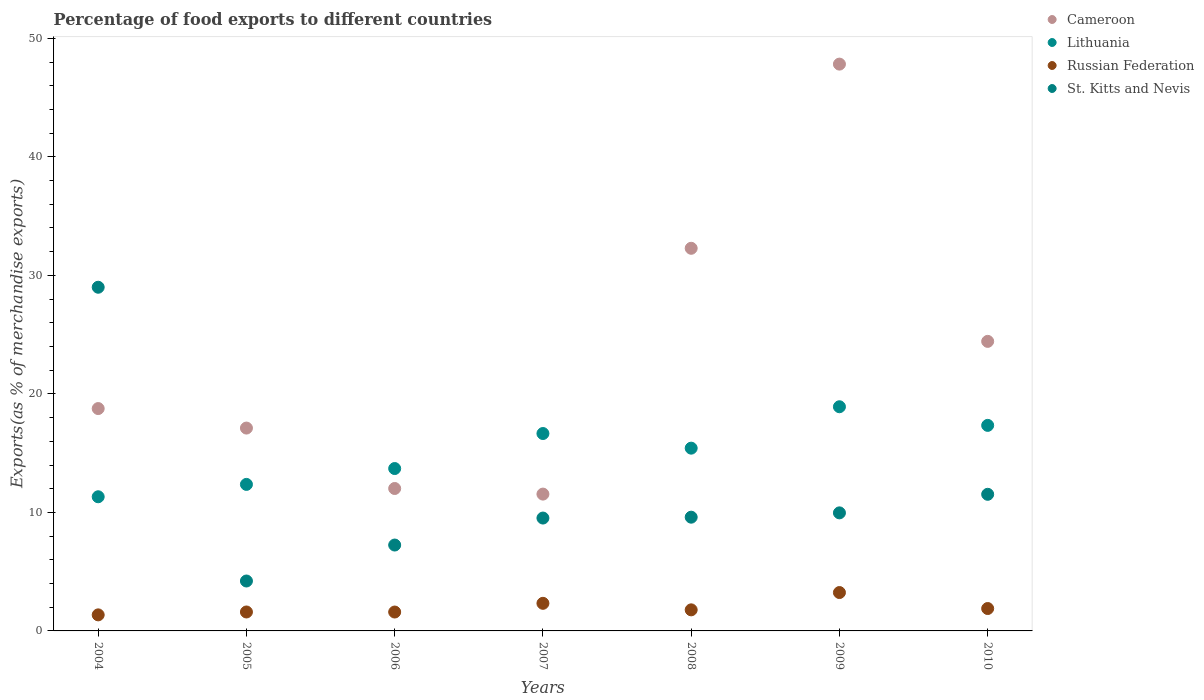Is the number of dotlines equal to the number of legend labels?
Provide a short and direct response. Yes. What is the percentage of exports to different countries in St. Kitts and Nevis in 2009?
Your answer should be compact. 9.96. Across all years, what is the maximum percentage of exports to different countries in Cameroon?
Make the answer very short. 47.83. Across all years, what is the minimum percentage of exports to different countries in St. Kitts and Nevis?
Your answer should be very brief. 4.21. In which year was the percentage of exports to different countries in St. Kitts and Nevis maximum?
Your answer should be very brief. 2004. What is the total percentage of exports to different countries in Lithuania in the graph?
Provide a succinct answer. 105.72. What is the difference between the percentage of exports to different countries in Russian Federation in 2007 and that in 2009?
Offer a terse response. -0.91. What is the difference between the percentage of exports to different countries in St. Kitts and Nevis in 2006 and the percentage of exports to different countries in Russian Federation in 2004?
Your answer should be compact. 5.89. What is the average percentage of exports to different countries in Lithuania per year?
Offer a very short reply. 15.1. In the year 2007, what is the difference between the percentage of exports to different countries in St. Kitts and Nevis and percentage of exports to different countries in Lithuania?
Your response must be concise. -7.13. In how many years, is the percentage of exports to different countries in St. Kitts and Nevis greater than 6 %?
Your response must be concise. 6. What is the ratio of the percentage of exports to different countries in St. Kitts and Nevis in 2005 to that in 2010?
Offer a very short reply. 0.37. Is the difference between the percentage of exports to different countries in St. Kitts and Nevis in 2004 and 2008 greater than the difference between the percentage of exports to different countries in Lithuania in 2004 and 2008?
Keep it short and to the point. Yes. What is the difference between the highest and the second highest percentage of exports to different countries in St. Kitts and Nevis?
Ensure brevity in your answer.  17.47. What is the difference between the highest and the lowest percentage of exports to different countries in St. Kitts and Nevis?
Your answer should be very brief. 24.79. In how many years, is the percentage of exports to different countries in Russian Federation greater than the average percentage of exports to different countries in Russian Federation taken over all years?
Offer a very short reply. 2. Is it the case that in every year, the sum of the percentage of exports to different countries in Russian Federation and percentage of exports to different countries in Cameroon  is greater than the sum of percentage of exports to different countries in St. Kitts and Nevis and percentage of exports to different countries in Lithuania?
Your answer should be compact. No. Is it the case that in every year, the sum of the percentage of exports to different countries in St. Kitts and Nevis and percentage of exports to different countries in Lithuania  is greater than the percentage of exports to different countries in Russian Federation?
Offer a very short reply. Yes. Is the percentage of exports to different countries in St. Kitts and Nevis strictly greater than the percentage of exports to different countries in Russian Federation over the years?
Keep it short and to the point. Yes. Is the percentage of exports to different countries in St. Kitts and Nevis strictly less than the percentage of exports to different countries in Cameroon over the years?
Your answer should be very brief. No. How many years are there in the graph?
Make the answer very short. 7. What is the difference between two consecutive major ticks on the Y-axis?
Provide a succinct answer. 10. What is the title of the graph?
Give a very brief answer. Percentage of food exports to different countries. What is the label or title of the X-axis?
Provide a succinct answer. Years. What is the label or title of the Y-axis?
Keep it short and to the point. Exports(as % of merchandise exports). What is the Exports(as % of merchandise exports) of Cameroon in 2004?
Offer a very short reply. 18.76. What is the Exports(as % of merchandise exports) of Lithuania in 2004?
Your answer should be compact. 11.32. What is the Exports(as % of merchandise exports) in Russian Federation in 2004?
Offer a very short reply. 1.35. What is the Exports(as % of merchandise exports) of St. Kitts and Nevis in 2004?
Keep it short and to the point. 29. What is the Exports(as % of merchandise exports) of Cameroon in 2005?
Ensure brevity in your answer.  17.12. What is the Exports(as % of merchandise exports) in Lithuania in 2005?
Your answer should be compact. 12.36. What is the Exports(as % of merchandise exports) in Russian Federation in 2005?
Your answer should be very brief. 1.6. What is the Exports(as % of merchandise exports) of St. Kitts and Nevis in 2005?
Ensure brevity in your answer.  4.21. What is the Exports(as % of merchandise exports) in Cameroon in 2006?
Offer a very short reply. 12.02. What is the Exports(as % of merchandise exports) in Lithuania in 2006?
Ensure brevity in your answer.  13.7. What is the Exports(as % of merchandise exports) in Russian Federation in 2006?
Make the answer very short. 1.59. What is the Exports(as % of merchandise exports) of St. Kitts and Nevis in 2006?
Your response must be concise. 7.25. What is the Exports(as % of merchandise exports) in Cameroon in 2007?
Offer a terse response. 11.54. What is the Exports(as % of merchandise exports) of Lithuania in 2007?
Your answer should be very brief. 16.66. What is the Exports(as % of merchandise exports) in Russian Federation in 2007?
Give a very brief answer. 2.33. What is the Exports(as % of merchandise exports) in St. Kitts and Nevis in 2007?
Make the answer very short. 9.52. What is the Exports(as % of merchandise exports) in Cameroon in 2008?
Provide a short and direct response. 32.29. What is the Exports(as % of merchandise exports) of Lithuania in 2008?
Provide a succinct answer. 15.42. What is the Exports(as % of merchandise exports) in Russian Federation in 2008?
Your answer should be compact. 1.78. What is the Exports(as % of merchandise exports) of St. Kitts and Nevis in 2008?
Keep it short and to the point. 9.6. What is the Exports(as % of merchandise exports) in Cameroon in 2009?
Offer a terse response. 47.83. What is the Exports(as % of merchandise exports) of Lithuania in 2009?
Make the answer very short. 18.92. What is the Exports(as % of merchandise exports) of Russian Federation in 2009?
Keep it short and to the point. 3.24. What is the Exports(as % of merchandise exports) in St. Kitts and Nevis in 2009?
Ensure brevity in your answer.  9.96. What is the Exports(as % of merchandise exports) of Cameroon in 2010?
Offer a very short reply. 24.43. What is the Exports(as % of merchandise exports) in Lithuania in 2010?
Ensure brevity in your answer.  17.34. What is the Exports(as % of merchandise exports) in Russian Federation in 2010?
Provide a succinct answer. 1.89. What is the Exports(as % of merchandise exports) in St. Kitts and Nevis in 2010?
Ensure brevity in your answer.  11.53. Across all years, what is the maximum Exports(as % of merchandise exports) of Cameroon?
Offer a very short reply. 47.83. Across all years, what is the maximum Exports(as % of merchandise exports) of Lithuania?
Your response must be concise. 18.92. Across all years, what is the maximum Exports(as % of merchandise exports) of Russian Federation?
Offer a very short reply. 3.24. Across all years, what is the maximum Exports(as % of merchandise exports) of St. Kitts and Nevis?
Provide a succinct answer. 29. Across all years, what is the minimum Exports(as % of merchandise exports) of Cameroon?
Keep it short and to the point. 11.54. Across all years, what is the minimum Exports(as % of merchandise exports) in Lithuania?
Keep it short and to the point. 11.32. Across all years, what is the minimum Exports(as % of merchandise exports) of Russian Federation?
Offer a very short reply. 1.35. Across all years, what is the minimum Exports(as % of merchandise exports) of St. Kitts and Nevis?
Keep it short and to the point. 4.21. What is the total Exports(as % of merchandise exports) in Cameroon in the graph?
Provide a succinct answer. 163.98. What is the total Exports(as % of merchandise exports) of Lithuania in the graph?
Your answer should be very brief. 105.72. What is the total Exports(as % of merchandise exports) in Russian Federation in the graph?
Ensure brevity in your answer.  13.78. What is the total Exports(as % of merchandise exports) in St. Kitts and Nevis in the graph?
Ensure brevity in your answer.  81.07. What is the difference between the Exports(as % of merchandise exports) in Cameroon in 2004 and that in 2005?
Your response must be concise. 1.65. What is the difference between the Exports(as % of merchandise exports) of Lithuania in 2004 and that in 2005?
Your response must be concise. -1.04. What is the difference between the Exports(as % of merchandise exports) in Russian Federation in 2004 and that in 2005?
Give a very brief answer. -0.24. What is the difference between the Exports(as % of merchandise exports) of St. Kitts and Nevis in 2004 and that in 2005?
Your answer should be compact. 24.79. What is the difference between the Exports(as % of merchandise exports) in Cameroon in 2004 and that in 2006?
Provide a short and direct response. 6.74. What is the difference between the Exports(as % of merchandise exports) of Lithuania in 2004 and that in 2006?
Provide a succinct answer. -2.38. What is the difference between the Exports(as % of merchandise exports) in Russian Federation in 2004 and that in 2006?
Offer a terse response. -0.24. What is the difference between the Exports(as % of merchandise exports) in St. Kitts and Nevis in 2004 and that in 2006?
Provide a short and direct response. 21.75. What is the difference between the Exports(as % of merchandise exports) in Cameroon in 2004 and that in 2007?
Offer a very short reply. 7.22. What is the difference between the Exports(as % of merchandise exports) in Lithuania in 2004 and that in 2007?
Your answer should be compact. -5.34. What is the difference between the Exports(as % of merchandise exports) of Russian Federation in 2004 and that in 2007?
Offer a terse response. -0.97. What is the difference between the Exports(as % of merchandise exports) in St. Kitts and Nevis in 2004 and that in 2007?
Keep it short and to the point. 19.48. What is the difference between the Exports(as % of merchandise exports) in Cameroon in 2004 and that in 2008?
Your response must be concise. -13.52. What is the difference between the Exports(as % of merchandise exports) of Lithuania in 2004 and that in 2008?
Keep it short and to the point. -4.1. What is the difference between the Exports(as % of merchandise exports) in Russian Federation in 2004 and that in 2008?
Provide a short and direct response. -0.42. What is the difference between the Exports(as % of merchandise exports) in St. Kitts and Nevis in 2004 and that in 2008?
Your answer should be compact. 19.4. What is the difference between the Exports(as % of merchandise exports) in Cameroon in 2004 and that in 2009?
Your answer should be compact. -29.06. What is the difference between the Exports(as % of merchandise exports) in Lithuania in 2004 and that in 2009?
Make the answer very short. -7.6. What is the difference between the Exports(as % of merchandise exports) in Russian Federation in 2004 and that in 2009?
Offer a terse response. -1.88. What is the difference between the Exports(as % of merchandise exports) in St. Kitts and Nevis in 2004 and that in 2009?
Provide a succinct answer. 19.04. What is the difference between the Exports(as % of merchandise exports) of Cameroon in 2004 and that in 2010?
Provide a succinct answer. -5.67. What is the difference between the Exports(as % of merchandise exports) in Lithuania in 2004 and that in 2010?
Ensure brevity in your answer.  -6.02. What is the difference between the Exports(as % of merchandise exports) of Russian Federation in 2004 and that in 2010?
Provide a short and direct response. -0.54. What is the difference between the Exports(as % of merchandise exports) in St. Kitts and Nevis in 2004 and that in 2010?
Keep it short and to the point. 17.47. What is the difference between the Exports(as % of merchandise exports) of Cameroon in 2005 and that in 2006?
Offer a terse response. 5.1. What is the difference between the Exports(as % of merchandise exports) of Lithuania in 2005 and that in 2006?
Make the answer very short. -1.34. What is the difference between the Exports(as % of merchandise exports) of Russian Federation in 2005 and that in 2006?
Keep it short and to the point. 0. What is the difference between the Exports(as % of merchandise exports) of St. Kitts and Nevis in 2005 and that in 2006?
Offer a terse response. -3.03. What is the difference between the Exports(as % of merchandise exports) in Cameroon in 2005 and that in 2007?
Make the answer very short. 5.57. What is the difference between the Exports(as % of merchandise exports) in Lithuania in 2005 and that in 2007?
Make the answer very short. -4.29. What is the difference between the Exports(as % of merchandise exports) in Russian Federation in 2005 and that in 2007?
Your answer should be very brief. -0.73. What is the difference between the Exports(as % of merchandise exports) in St. Kitts and Nevis in 2005 and that in 2007?
Keep it short and to the point. -5.31. What is the difference between the Exports(as % of merchandise exports) in Cameroon in 2005 and that in 2008?
Give a very brief answer. -15.17. What is the difference between the Exports(as % of merchandise exports) of Lithuania in 2005 and that in 2008?
Your response must be concise. -3.06. What is the difference between the Exports(as % of merchandise exports) of Russian Federation in 2005 and that in 2008?
Provide a succinct answer. -0.18. What is the difference between the Exports(as % of merchandise exports) in St. Kitts and Nevis in 2005 and that in 2008?
Your response must be concise. -5.38. What is the difference between the Exports(as % of merchandise exports) of Cameroon in 2005 and that in 2009?
Offer a terse response. -30.71. What is the difference between the Exports(as % of merchandise exports) in Lithuania in 2005 and that in 2009?
Provide a short and direct response. -6.55. What is the difference between the Exports(as % of merchandise exports) of Russian Federation in 2005 and that in 2009?
Keep it short and to the point. -1.64. What is the difference between the Exports(as % of merchandise exports) of St. Kitts and Nevis in 2005 and that in 2009?
Ensure brevity in your answer.  -5.75. What is the difference between the Exports(as % of merchandise exports) in Cameroon in 2005 and that in 2010?
Your answer should be very brief. -7.32. What is the difference between the Exports(as % of merchandise exports) of Lithuania in 2005 and that in 2010?
Offer a terse response. -4.98. What is the difference between the Exports(as % of merchandise exports) of Russian Federation in 2005 and that in 2010?
Offer a terse response. -0.29. What is the difference between the Exports(as % of merchandise exports) of St. Kitts and Nevis in 2005 and that in 2010?
Provide a short and direct response. -7.32. What is the difference between the Exports(as % of merchandise exports) of Cameroon in 2006 and that in 2007?
Offer a very short reply. 0.47. What is the difference between the Exports(as % of merchandise exports) of Lithuania in 2006 and that in 2007?
Keep it short and to the point. -2.96. What is the difference between the Exports(as % of merchandise exports) in Russian Federation in 2006 and that in 2007?
Make the answer very short. -0.73. What is the difference between the Exports(as % of merchandise exports) in St. Kitts and Nevis in 2006 and that in 2007?
Ensure brevity in your answer.  -2.28. What is the difference between the Exports(as % of merchandise exports) of Cameroon in 2006 and that in 2008?
Offer a very short reply. -20.27. What is the difference between the Exports(as % of merchandise exports) of Lithuania in 2006 and that in 2008?
Your answer should be very brief. -1.72. What is the difference between the Exports(as % of merchandise exports) of Russian Federation in 2006 and that in 2008?
Your answer should be very brief. -0.18. What is the difference between the Exports(as % of merchandise exports) of St. Kitts and Nevis in 2006 and that in 2008?
Provide a short and direct response. -2.35. What is the difference between the Exports(as % of merchandise exports) of Cameroon in 2006 and that in 2009?
Your response must be concise. -35.81. What is the difference between the Exports(as % of merchandise exports) in Lithuania in 2006 and that in 2009?
Keep it short and to the point. -5.21. What is the difference between the Exports(as % of merchandise exports) in Russian Federation in 2006 and that in 2009?
Give a very brief answer. -1.64. What is the difference between the Exports(as % of merchandise exports) in St. Kitts and Nevis in 2006 and that in 2009?
Give a very brief answer. -2.71. What is the difference between the Exports(as % of merchandise exports) in Cameroon in 2006 and that in 2010?
Offer a very short reply. -12.41. What is the difference between the Exports(as % of merchandise exports) of Lithuania in 2006 and that in 2010?
Your answer should be compact. -3.64. What is the difference between the Exports(as % of merchandise exports) in Russian Federation in 2006 and that in 2010?
Offer a very short reply. -0.3. What is the difference between the Exports(as % of merchandise exports) in St. Kitts and Nevis in 2006 and that in 2010?
Your response must be concise. -4.28. What is the difference between the Exports(as % of merchandise exports) in Cameroon in 2007 and that in 2008?
Provide a short and direct response. -20.74. What is the difference between the Exports(as % of merchandise exports) in Lithuania in 2007 and that in 2008?
Your response must be concise. 1.24. What is the difference between the Exports(as % of merchandise exports) of Russian Federation in 2007 and that in 2008?
Offer a very short reply. 0.55. What is the difference between the Exports(as % of merchandise exports) of St. Kitts and Nevis in 2007 and that in 2008?
Offer a terse response. -0.07. What is the difference between the Exports(as % of merchandise exports) of Cameroon in 2007 and that in 2009?
Your answer should be compact. -36.28. What is the difference between the Exports(as % of merchandise exports) of Lithuania in 2007 and that in 2009?
Keep it short and to the point. -2.26. What is the difference between the Exports(as % of merchandise exports) in Russian Federation in 2007 and that in 2009?
Your answer should be compact. -0.91. What is the difference between the Exports(as % of merchandise exports) of St. Kitts and Nevis in 2007 and that in 2009?
Give a very brief answer. -0.44. What is the difference between the Exports(as % of merchandise exports) of Cameroon in 2007 and that in 2010?
Make the answer very short. -12.89. What is the difference between the Exports(as % of merchandise exports) in Lithuania in 2007 and that in 2010?
Offer a terse response. -0.69. What is the difference between the Exports(as % of merchandise exports) of Russian Federation in 2007 and that in 2010?
Give a very brief answer. 0.44. What is the difference between the Exports(as % of merchandise exports) in St. Kitts and Nevis in 2007 and that in 2010?
Make the answer very short. -2. What is the difference between the Exports(as % of merchandise exports) of Cameroon in 2008 and that in 2009?
Your answer should be compact. -15.54. What is the difference between the Exports(as % of merchandise exports) in Lithuania in 2008 and that in 2009?
Provide a succinct answer. -3.49. What is the difference between the Exports(as % of merchandise exports) in Russian Federation in 2008 and that in 2009?
Ensure brevity in your answer.  -1.46. What is the difference between the Exports(as % of merchandise exports) in St. Kitts and Nevis in 2008 and that in 2009?
Make the answer very short. -0.36. What is the difference between the Exports(as % of merchandise exports) of Cameroon in 2008 and that in 2010?
Keep it short and to the point. 7.85. What is the difference between the Exports(as % of merchandise exports) of Lithuania in 2008 and that in 2010?
Provide a short and direct response. -1.92. What is the difference between the Exports(as % of merchandise exports) of Russian Federation in 2008 and that in 2010?
Make the answer very short. -0.11. What is the difference between the Exports(as % of merchandise exports) of St. Kitts and Nevis in 2008 and that in 2010?
Your answer should be very brief. -1.93. What is the difference between the Exports(as % of merchandise exports) of Cameroon in 2009 and that in 2010?
Make the answer very short. 23.39. What is the difference between the Exports(as % of merchandise exports) of Lithuania in 2009 and that in 2010?
Your answer should be very brief. 1.57. What is the difference between the Exports(as % of merchandise exports) in Russian Federation in 2009 and that in 2010?
Give a very brief answer. 1.35. What is the difference between the Exports(as % of merchandise exports) in St. Kitts and Nevis in 2009 and that in 2010?
Your answer should be very brief. -1.57. What is the difference between the Exports(as % of merchandise exports) in Cameroon in 2004 and the Exports(as % of merchandise exports) in Lithuania in 2005?
Provide a succinct answer. 6.4. What is the difference between the Exports(as % of merchandise exports) in Cameroon in 2004 and the Exports(as % of merchandise exports) in Russian Federation in 2005?
Keep it short and to the point. 17.16. What is the difference between the Exports(as % of merchandise exports) of Cameroon in 2004 and the Exports(as % of merchandise exports) of St. Kitts and Nevis in 2005?
Provide a short and direct response. 14.55. What is the difference between the Exports(as % of merchandise exports) of Lithuania in 2004 and the Exports(as % of merchandise exports) of Russian Federation in 2005?
Your answer should be compact. 9.72. What is the difference between the Exports(as % of merchandise exports) of Lithuania in 2004 and the Exports(as % of merchandise exports) of St. Kitts and Nevis in 2005?
Offer a terse response. 7.11. What is the difference between the Exports(as % of merchandise exports) of Russian Federation in 2004 and the Exports(as % of merchandise exports) of St. Kitts and Nevis in 2005?
Keep it short and to the point. -2.86. What is the difference between the Exports(as % of merchandise exports) of Cameroon in 2004 and the Exports(as % of merchandise exports) of Lithuania in 2006?
Provide a short and direct response. 5.06. What is the difference between the Exports(as % of merchandise exports) of Cameroon in 2004 and the Exports(as % of merchandise exports) of Russian Federation in 2006?
Ensure brevity in your answer.  17.17. What is the difference between the Exports(as % of merchandise exports) of Cameroon in 2004 and the Exports(as % of merchandise exports) of St. Kitts and Nevis in 2006?
Give a very brief answer. 11.52. What is the difference between the Exports(as % of merchandise exports) in Lithuania in 2004 and the Exports(as % of merchandise exports) in Russian Federation in 2006?
Give a very brief answer. 9.73. What is the difference between the Exports(as % of merchandise exports) in Lithuania in 2004 and the Exports(as % of merchandise exports) in St. Kitts and Nevis in 2006?
Make the answer very short. 4.07. What is the difference between the Exports(as % of merchandise exports) of Russian Federation in 2004 and the Exports(as % of merchandise exports) of St. Kitts and Nevis in 2006?
Offer a very short reply. -5.89. What is the difference between the Exports(as % of merchandise exports) in Cameroon in 2004 and the Exports(as % of merchandise exports) in Lithuania in 2007?
Your response must be concise. 2.11. What is the difference between the Exports(as % of merchandise exports) of Cameroon in 2004 and the Exports(as % of merchandise exports) of Russian Federation in 2007?
Offer a terse response. 16.43. What is the difference between the Exports(as % of merchandise exports) of Cameroon in 2004 and the Exports(as % of merchandise exports) of St. Kitts and Nevis in 2007?
Offer a very short reply. 9.24. What is the difference between the Exports(as % of merchandise exports) of Lithuania in 2004 and the Exports(as % of merchandise exports) of Russian Federation in 2007?
Offer a very short reply. 8.99. What is the difference between the Exports(as % of merchandise exports) of Lithuania in 2004 and the Exports(as % of merchandise exports) of St. Kitts and Nevis in 2007?
Give a very brief answer. 1.8. What is the difference between the Exports(as % of merchandise exports) of Russian Federation in 2004 and the Exports(as % of merchandise exports) of St. Kitts and Nevis in 2007?
Provide a succinct answer. -8.17. What is the difference between the Exports(as % of merchandise exports) in Cameroon in 2004 and the Exports(as % of merchandise exports) in Lithuania in 2008?
Offer a terse response. 3.34. What is the difference between the Exports(as % of merchandise exports) in Cameroon in 2004 and the Exports(as % of merchandise exports) in Russian Federation in 2008?
Provide a succinct answer. 16.98. What is the difference between the Exports(as % of merchandise exports) in Cameroon in 2004 and the Exports(as % of merchandise exports) in St. Kitts and Nevis in 2008?
Your answer should be very brief. 9.17. What is the difference between the Exports(as % of merchandise exports) in Lithuania in 2004 and the Exports(as % of merchandise exports) in Russian Federation in 2008?
Your answer should be compact. 9.54. What is the difference between the Exports(as % of merchandise exports) in Lithuania in 2004 and the Exports(as % of merchandise exports) in St. Kitts and Nevis in 2008?
Provide a short and direct response. 1.72. What is the difference between the Exports(as % of merchandise exports) in Russian Federation in 2004 and the Exports(as % of merchandise exports) in St. Kitts and Nevis in 2008?
Keep it short and to the point. -8.24. What is the difference between the Exports(as % of merchandise exports) of Cameroon in 2004 and the Exports(as % of merchandise exports) of Lithuania in 2009?
Keep it short and to the point. -0.15. What is the difference between the Exports(as % of merchandise exports) of Cameroon in 2004 and the Exports(as % of merchandise exports) of Russian Federation in 2009?
Your answer should be very brief. 15.52. What is the difference between the Exports(as % of merchandise exports) in Cameroon in 2004 and the Exports(as % of merchandise exports) in St. Kitts and Nevis in 2009?
Your response must be concise. 8.8. What is the difference between the Exports(as % of merchandise exports) of Lithuania in 2004 and the Exports(as % of merchandise exports) of Russian Federation in 2009?
Your answer should be very brief. 8.08. What is the difference between the Exports(as % of merchandise exports) of Lithuania in 2004 and the Exports(as % of merchandise exports) of St. Kitts and Nevis in 2009?
Your response must be concise. 1.36. What is the difference between the Exports(as % of merchandise exports) of Russian Federation in 2004 and the Exports(as % of merchandise exports) of St. Kitts and Nevis in 2009?
Your answer should be very brief. -8.61. What is the difference between the Exports(as % of merchandise exports) of Cameroon in 2004 and the Exports(as % of merchandise exports) of Lithuania in 2010?
Keep it short and to the point. 1.42. What is the difference between the Exports(as % of merchandise exports) in Cameroon in 2004 and the Exports(as % of merchandise exports) in Russian Federation in 2010?
Keep it short and to the point. 16.87. What is the difference between the Exports(as % of merchandise exports) of Cameroon in 2004 and the Exports(as % of merchandise exports) of St. Kitts and Nevis in 2010?
Give a very brief answer. 7.23. What is the difference between the Exports(as % of merchandise exports) of Lithuania in 2004 and the Exports(as % of merchandise exports) of Russian Federation in 2010?
Provide a short and direct response. 9.43. What is the difference between the Exports(as % of merchandise exports) of Lithuania in 2004 and the Exports(as % of merchandise exports) of St. Kitts and Nevis in 2010?
Provide a succinct answer. -0.21. What is the difference between the Exports(as % of merchandise exports) of Russian Federation in 2004 and the Exports(as % of merchandise exports) of St. Kitts and Nevis in 2010?
Your answer should be very brief. -10.17. What is the difference between the Exports(as % of merchandise exports) in Cameroon in 2005 and the Exports(as % of merchandise exports) in Lithuania in 2006?
Your answer should be very brief. 3.41. What is the difference between the Exports(as % of merchandise exports) of Cameroon in 2005 and the Exports(as % of merchandise exports) of Russian Federation in 2006?
Keep it short and to the point. 15.52. What is the difference between the Exports(as % of merchandise exports) of Cameroon in 2005 and the Exports(as % of merchandise exports) of St. Kitts and Nevis in 2006?
Keep it short and to the point. 9.87. What is the difference between the Exports(as % of merchandise exports) in Lithuania in 2005 and the Exports(as % of merchandise exports) in Russian Federation in 2006?
Give a very brief answer. 10.77. What is the difference between the Exports(as % of merchandise exports) in Lithuania in 2005 and the Exports(as % of merchandise exports) in St. Kitts and Nevis in 2006?
Give a very brief answer. 5.12. What is the difference between the Exports(as % of merchandise exports) in Russian Federation in 2005 and the Exports(as % of merchandise exports) in St. Kitts and Nevis in 2006?
Your response must be concise. -5.65. What is the difference between the Exports(as % of merchandise exports) of Cameroon in 2005 and the Exports(as % of merchandise exports) of Lithuania in 2007?
Give a very brief answer. 0.46. What is the difference between the Exports(as % of merchandise exports) in Cameroon in 2005 and the Exports(as % of merchandise exports) in Russian Federation in 2007?
Offer a very short reply. 14.79. What is the difference between the Exports(as % of merchandise exports) in Cameroon in 2005 and the Exports(as % of merchandise exports) in St. Kitts and Nevis in 2007?
Your response must be concise. 7.59. What is the difference between the Exports(as % of merchandise exports) of Lithuania in 2005 and the Exports(as % of merchandise exports) of Russian Federation in 2007?
Ensure brevity in your answer.  10.03. What is the difference between the Exports(as % of merchandise exports) in Lithuania in 2005 and the Exports(as % of merchandise exports) in St. Kitts and Nevis in 2007?
Your answer should be compact. 2.84. What is the difference between the Exports(as % of merchandise exports) in Russian Federation in 2005 and the Exports(as % of merchandise exports) in St. Kitts and Nevis in 2007?
Ensure brevity in your answer.  -7.93. What is the difference between the Exports(as % of merchandise exports) in Cameroon in 2005 and the Exports(as % of merchandise exports) in Lithuania in 2008?
Ensure brevity in your answer.  1.69. What is the difference between the Exports(as % of merchandise exports) of Cameroon in 2005 and the Exports(as % of merchandise exports) of Russian Federation in 2008?
Offer a terse response. 15.34. What is the difference between the Exports(as % of merchandise exports) of Cameroon in 2005 and the Exports(as % of merchandise exports) of St. Kitts and Nevis in 2008?
Offer a very short reply. 7.52. What is the difference between the Exports(as % of merchandise exports) of Lithuania in 2005 and the Exports(as % of merchandise exports) of Russian Federation in 2008?
Ensure brevity in your answer.  10.59. What is the difference between the Exports(as % of merchandise exports) in Lithuania in 2005 and the Exports(as % of merchandise exports) in St. Kitts and Nevis in 2008?
Give a very brief answer. 2.77. What is the difference between the Exports(as % of merchandise exports) in Russian Federation in 2005 and the Exports(as % of merchandise exports) in St. Kitts and Nevis in 2008?
Your answer should be very brief. -8. What is the difference between the Exports(as % of merchandise exports) in Cameroon in 2005 and the Exports(as % of merchandise exports) in Lithuania in 2009?
Keep it short and to the point. -1.8. What is the difference between the Exports(as % of merchandise exports) in Cameroon in 2005 and the Exports(as % of merchandise exports) in Russian Federation in 2009?
Keep it short and to the point. 13.88. What is the difference between the Exports(as % of merchandise exports) in Cameroon in 2005 and the Exports(as % of merchandise exports) in St. Kitts and Nevis in 2009?
Your answer should be compact. 7.15. What is the difference between the Exports(as % of merchandise exports) in Lithuania in 2005 and the Exports(as % of merchandise exports) in Russian Federation in 2009?
Your answer should be very brief. 9.12. What is the difference between the Exports(as % of merchandise exports) in Lithuania in 2005 and the Exports(as % of merchandise exports) in St. Kitts and Nevis in 2009?
Offer a very short reply. 2.4. What is the difference between the Exports(as % of merchandise exports) in Russian Federation in 2005 and the Exports(as % of merchandise exports) in St. Kitts and Nevis in 2009?
Provide a succinct answer. -8.36. What is the difference between the Exports(as % of merchandise exports) in Cameroon in 2005 and the Exports(as % of merchandise exports) in Lithuania in 2010?
Provide a short and direct response. -0.23. What is the difference between the Exports(as % of merchandise exports) in Cameroon in 2005 and the Exports(as % of merchandise exports) in Russian Federation in 2010?
Your answer should be compact. 15.23. What is the difference between the Exports(as % of merchandise exports) in Cameroon in 2005 and the Exports(as % of merchandise exports) in St. Kitts and Nevis in 2010?
Ensure brevity in your answer.  5.59. What is the difference between the Exports(as % of merchandise exports) of Lithuania in 2005 and the Exports(as % of merchandise exports) of Russian Federation in 2010?
Make the answer very short. 10.47. What is the difference between the Exports(as % of merchandise exports) in Lithuania in 2005 and the Exports(as % of merchandise exports) in St. Kitts and Nevis in 2010?
Your answer should be very brief. 0.84. What is the difference between the Exports(as % of merchandise exports) of Russian Federation in 2005 and the Exports(as % of merchandise exports) of St. Kitts and Nevis in 2010?
Provide a succinct answer. -9.93. What is the difference between the Exports(as % of merchandise exports) of Cameroon in 2006 and the Exports(as % of merchandise exports) of Lithuania in 2007?
Your answer should be compact. -4.64. What is the difference between the Exports(as % of merchandise exports) of Cameroon in 2006 and the Exports(as % of merchandise exports) of Russian Federation in 2007?
Your answer should be very brief. 9.69. What is the difference between the Exports(as % of merchandise exports) in Cameroon in 2006 and the Exports(as % of merchandise exports) in St. Kitts and Nevis in 2007?
Ensure brevity in your answer.  2.49. What is the difference between the Exports(as % of merchandise exports) in Lithuania in 2006 and the Exports(as % of merchandise exports) in Russian Federation in 2007?
Provide a succinct answer. 11.37. What is the difference between the Exports(as % of merchandise exports) of Lithuania in 2006 and the Exports(as % of merchandise exports) of St. Kitts and Nevis in 2007?
Your response must be concise. 4.18. What is the difference between the Exports(as % of merchandise exports) in Russian Federation in 2006 and the Exports(as % of merchandise exports) in St. Kitts and Nevis in 2007?
Keep it short and to the point. -7.93. What is the difference between the Exports(as % of merchandise exports) in Cameroon in 2006 and the Exports(as % of merchandise exports) in Lithuania in 2008?
Keep it short and to the point. -3.4. What is the difference between the Exports(as % of merchandise exports) of Cameroon in 2006 and the Exports(as % of merchandise exports) of Russian Federation in 2008?
Make the answer very short. 10.24. What is the difference between the Exports(as % of merchandise exports) of Cameroon in 2006 and the Exports(as % of merchandise exports) of St. Kitts and Nevis in 2008?
Provide a short and direct response. 2.42. What is the difference between the Exports(as % of merchandise exports) in Lithuania in 2006 and the Exports(as % of merchandise exports) in Russian Federation in 2008?
Offer a terse response. 11.92. What is the difference between the Exports(as % of merchandise exports) in Lithuania in 2006 and the Exports(as % of merchandise exports) in St. Kitts and Nevis in 2008?
Give a very brief answer. 4.1. What is the difference between the Exports(as % of merchandise exports) of Russian Federation in 2006 and the Exports(as % of merchandise exports) of St. Kitts and Nevis in 2008?
Your answer should be very brief. -8. What is the difference between the Exports(as % of merchandise exports) in Cameroon in 2006 and the Exports(as % of merchandise exports) in Lithuania in 2009?
Provide a short and direct response. -6.9. What is the difference between the Exports(as % of merchandise exports) of Cameroon in 2006 and the Exports(as % of merchandise exports) of Russian Federation in 2009?
Your answer should be very brief. 8.78. What is the difference between the Exports(as % of merchandise exports) in Cameroon in 2006 and the Exports(as % of merchandise exports) in St. Kitts and Nevis in 2009?
Offer a terse response. 2.06. What is the difference between the Exports(as % of merchandise exports) of Lithuania in 2006 and the Exports(as % of merchandise exports) of Russian Federation in 2009?
Offer a terse response. 10.46. What is the difference between the Exports(as % of merchandise exports) in Lithuania in 2006 and the Exports(as % of merchandise exports) in St. Kitts and Nevis in 2009?
Ensure brevity in your answer.  3.74. What is the difference between the Exports(as % of merchandise exports) of Russian Federation in 2006 and the Exports(as % of merchandise exports) of St. Kitts and Nevis in 2009?
Make the answer very short. -8.37. What is the difference between the Exports(as % of merchandise exports) of Cameroon in 2006 and the Exports(as % of merchandise exports) of Lithuania in 2010?
Offer a terse response. -5.33. What is the difference between the Exports(as % of merchandise exports) of Cameroon in 2006 and the Exports(as % of merchandise exports) of Russian Federation in 2010?
Your answer should be very brief. 10.13. What is the difference between the Exports(as % of merchandise exports) in Cameroon in 2006 and the Exports(as % of merchandise exports) in St. Kitts and Nevis in 2010?
Ensure brevity in your answer.  0.49. What is the difference between the Exports(as % of merchandise exports) in Lithuania in 2006 and the Exports(as % of merchandise exports) in Russian Federation in 2010?
Make the answer very short. 11.81. What is the difference between the Exports(as % of merchandise exports) in Lithuania in 2006 and the Exports(as % of merchandise exports) in St. Kitts and Nevis in 2010?
Your response must be concise. 2.17. What is the difference between the Exports(as % of merchandise exports) in Russian Federation in 2006 and the Exports(as % of merchandise exports) in St. Kitts and Nevis in 2010?
Keep it short and to the point. -9.93. What is the difference between the Exports(as % of merchandise exports) in Cameroon in 2007 and the Exports(as % of merchandise exports) in Lithuania in 2008?
Make the answer very short. -3.88. What is the difference between the Exports(as % of merchandise exports) of Cameroon in 2007 and the Exports(as % of merchandise exports) of Russian Federation in 2008?
Provide a short and direct response. 9.77. What is the difference between the Exports(as % of merchandise exports) of Cameroon in 2007 and the Exports(as % of merchandise exports) of St. Kitts and Nevis in 2008?
Offer a very short reply. 1.95. What is the difference between the Exports(as % of merchandise exports) of Lithuania in 2007 and the Exports(as % of merchandise exports) of Russian Federation in 2008?
Make the answer very short. 14.88. What is the difference between the Exports(as % of merchandise exports) in Lithuania in 2007 and the Exports(as % of merchandise exports) in St. Kitts and Nevis in 2008?
Provide a succinct answer. 7.06. What is the difference between the Exports(as % of merchandise exports) in Russian Federation in 2007 and the Exports(as % of merchandise exports) in St. Kitts and Nevis in 2008?
Ensure brevity in your answer.  -7.27. What is the difference between the Exports(as % of merchandise exports) in Cameroon in 2007 and the Exports(as % of merchandise exports) in Lithuania in 2009?
Ensure brevity in your answer.  -7.37. What is the difference between the Exports(as % of merchandise exports) of Cameroon in 2007 and the Exports(as % of merchandise exports) of Russian Federation in 2009?
Make the answer very short. 8.31. What is the difference between the Exports(as % of merchandise exports) in Cameroon in 2007 and the Exports(as % of merchandise exports) in St. Kitts and Nevis in 2009?
Offer a terse response. 1.58. What is the difference between the Exports(as % of merchandise exports) in Lithuania in 2007 and the Exports(as % of merchandise exports) in Russian Federation in 2009?
Make the answer very short. 13.42. What is the difference between the Exports(as % of merchandise exports) of Lithuania in 2007 and the Exports(as % of merchandise exports) of St. Kitts and Nevis in 2009?
Your answer should be compact. 6.69. What is the difference between the Exports(as % of merchandise exports) of Russian Federation in 2007 and the Exports(as % of merchandise exports) of St. Kitts and Nevis in 2009?
Provide a succinct answer. -7.63. What is the difference between the Exports(as % of merchandise exports) in Cameroon in 2007 and the Exports(as % of merchandise exports) in Lithuania in 2010?
Offer a terse response. -5.8. What is the difference between the Exports(as % of merchandise exports) in Cameroon in 2007 and the Exports(as % of merchandise exports) in Russian Federation in 2010?
Offer a terse response. 9.65. What is the difference between the Exports(as % of merchandise exports) of Cameroon in 2007 and the Exports(as % of merchandise exports) of St. Kitts and Nevis in 2010?
Offer a terse response. 0.02. What is the difference between the Exports(as % of merchandise exports) of Lithuania in 2007 and the Exports(as % of merchandise exports) of Russian Federation in 2010?
Your answer should be very brief. 14.77. What is the difference between the Exports(as % of merchandise exports) in Lithuania in 2007 and the Exports(as % of merchandise exports) in St. Kitts and Nevis in 2010?
Keep it short and to the point. 5.13. What is the difference between the Exports(as % of merchandise exports) of Russian Federation in 2007 and the Exports(as % of merchandise exports) of St. Kitts and Nevis in 2010?
Your response must be concise. -9.2. What is the difference between the Exports(as % of merchandise exports) of Cameroon in 2008 and the Exports(as % of merchandise exports) of Lithuania in 2009?
Make the answer very short. 13.37. What is the difference between the Exports(as % of merchandise exports) of Cameroon in 2008 and the Exports(as % of merchandise exports) of Russian Federation in 2009?
Your response must be concise. 29.05. What is the difference between the Exports(as % of merchandise exports) in Cameroon in 2008 and the Exports(as % of merchandise exports) in St. Kitts and Nevis in 2009?
Offer a very short reply. 22.32. What is the difference between the Exports(as % of merchandise exports) of Lithuania in 2008 and the Exports(as % of merchandise exports) of Russian Federation in 2009?
Provide a succinct answer. 12.18. What is the difference between the Exports(as % of merchandise exports) in Lithuania in 2008 and the Exports(as % of merchandise exports) in St. Kitts and Nevis in 2009?
Your response must be concise. 5.46. What is the difference between the Exports(as % of merchandise exports) in Russian Federation in 2008 and the Exports(as % of merchandise exports) in St. Kitts and Nevis in 2009?
Your answer should be very brief. -8.18. What is the difference between the Exports(as % of merchandise exports) of Cameroon in 2008 and the Exports(as % of merchandise exports) of Lithuania in 2010?
Your answer should be very brief. 14.94. What is the difference between the Exports(as % of merchandise exports) in Cameroon in 2008 and the Exports(as % of merchandise exports) in Russian Federation in 2010?
Your answer should be compact. 30.4. What is the difference between the Exports(as % of merchandise exports) in Cameroon in 2008 and the Exports(as % of merchandise exports) in St. Kitts and Nevis in 2010?
Your response must be concise. 20.76. What is the difference between the Exports(as % of merchandise exports) in Lithuania in 2008 and the Exports(as % of merchandise exports) in Russian Federation in 2010?
Ensure brevity in your answer.  13.53. What is the difference between the Exports(as % of merchandise exports) in Lithuania in 2008 and the Exports(as % of merchandise exports) in St. Kitts and Nevis in 2010?
Your answer should be very brief. 3.89. What is the difference between the Exports(as % of merchandise exports) in Russian Federation in 2008 and the Exports(as % of merchandise exports) in St. Kitts and Nevis in 2010?
Make the answer very short. -9.75. What is the difference between the Exports(as % of merchandise exports) of Cameroon in 2009 and the Exports(as % of merchandise exports) of Lithuania in 2010?
Offer a terse response. 30.48. What is the difference between the Exports(as % of merchandise exports) of Cameroon in 2009 and the Exports(as % of merchandise exports) of Russian Federation in 2010?
Give a very brief answer. 45.94. What is the difference between the Exports(as % of merchandise exports) in Cameroon in 2009 and the Exports(as % of merchandise exports) in St. Kitts and Nevis in 2010?
Ensure brevity in your answer.  36.3. What is the difference between the Exports(as % of merchandise exports) of Lithuania in 2009 and the Exports(as % of merchandise exports) of Russian Federation in 2010?
Your answer should be compact. 17.03. What is the difference between the Exports(as % of merchandise exports) of Lithuania in 2009 and the Exports(as % of merchandise exports) of St. Kitts and Nevis in 2010?
Your answer should be very brief. 7.39. What is the difference between the Exports(as % of merchandise exports) of Russian Federation in 2009 and the Exports(as % of merchandise exports) of St. Kitts and Nevis in 2010?
Make the answer very short. -8.29. What is the average Exports(as % of merchandise exports) of Cameroon per year?
Your response must be concise. 23.43. What is the average Exports(as % of merchandise exports) of Lithuania per year?
Make the answer very short. 15.1. What is the average Exports(as % of merchandise exports) of Russian Federation per year?
Give a very brief answer. 1.97. What is the average Exports(as % of merchandise exports) in St. Kitts and Nevis per year?
Your response must be concise. 11.58. In the year 2004, what is the difference between the Exports(as % of merchandise exports) in Cameroon and Exports(as % of merchandise exports) in Lithuania?
Give a very brief answer. 7.44. In the year 2004, what is the difference between the Exports(as % of merchandise exports) in Cameroon and Exports(as % of merchandise exports) in Russian Federation?
Offer a terse response. 17.41. In the year 2004, what is the difference between the Exports(as % of merchandise exports) in Cameroon and Exports(as % of merchandise exports) in St. Kitts and Nevis?
Your answer should be very brief. -10.24. In the year 2004, what is the difference between the Exports(as % of merchandise exports) of Lithuania and Exports(as % of merchandise exports) of Russian Federation?
Give a very brief answer. 9.97. In the year 2004, what is the difference between the Exports(as % of merchandise exports) in Lithuania and Exports(as % of merchandise exports) in St. Kitts and Nevis?
Offer a very short reply. -17.68. In the year 2004, what is the difference between the Exports(as % of merchandise exports) in Russian Federation and Exports(as % of merchandise exports) in St. Kitts and Nevis?
Offer a terse response. -27.64. In the year 2005, what is the difference between the Exports(as % of merchandise exports) in Cameroon and Exports(as % of merchandise exports) in Lithuania?
Ensure brevity in your answer.  4.75. In the year 2005, what is the difference between the Exports(as % of merchandise exports) of Cameroon and Exports(as % of merchandise exports) of Russian Federation?
Your answer should be very brief. 15.52. In the year 2005, what is the difference between the Exports(as % of merchandise exports) of Cameroon and Exports(as % of merchandise exports) of St. Kitts and Nevis?
Your response must be concise. 12.9. In the year 2005, what is the difference between the Exports(as % of merchandise exports) in Lithuania and Exports(as % of merchandise exports) in Russian Federation?
Ensure brevity in your answer.  10.77. In the year 2005, what is the difference between the Exports(as % of merchandise exports) in Lithuania and Exports(as % of merchandise exports) in St. Kitts and Nevis?
Make the answer very short. 8.15. In the year 2005, what is the difference between the Exports(as % of merchandise exports) in Russian Federation and Exports(as % of merchandise exports) in St. Kitts and Nevis?
Give a very brief answer. -2.61. In the year 2006, what is the difference between the Exports(as % of merchandise exports) of Cameroon and Exports(as % of merchandise exports) of Lithuania?
Give a very brief answer. -1.68. In the year 2006, what is the difference between the Exports(as % of merchandise exports) of Cameroon and Exports(as % of merchandise exports) of Russian Federation?
Your answer should be very brief. 10.42. In the year 2006, what is the difference between the Exports(as % of merchandise exports) in Cameroon and Exports(as % of merchandise exports) in St. Kitts and Nevis?
Give a very brief answer. 4.77. In the year 2006, what is the difference between the Exports(as % of merchandise exports) of Lithuania and Exports(as % of merchandise exports) of Russian Federation?
Give a very brief answer. 12.11. In the year 2006, what is the difference between the Exports(as % of merchandise exports) of Lithuania and Exports(as % of merchandise exports) of St. Kitts and Nevis?
Keep it short and to the point. 6.45. In the year 2006, what is the difference between the Exports(as % of merchandise exports) in Russian Federation and Exports(as % of merchandise exports) in St. Kitts and Nevis?
Offer a terse response. -5.65. In the year 2007, what is the difference between the Exports(as % of merchandise exports) of Cameroon and Exports(as % of merchandise exports) of Lithuania?
Give a very brief answer. -5.11. In the year 2007, what is the difference between the Exports(as % of merchandise exports) in Cameroon and Exports(as % of merchandise exports) in Russian Federation?
Offer a very short reply. 9.22. In the year 2007, what is the difference between the Exports(as % of merchandise exports) in Cameroon and Exports(as % of merchandise exports) in St. Kitts and Nevis?
Provide a succinct answer. 2.02. In the year 2007, what is the difference between the Exports(as % of merchandise exports) of Lithuania and Exports(as % of merchandise exports) of Russian Federation?
Keep it short and to the point. 14.33. In the year 2007, what is the difference between the Exports(as % of merchandise exports) of Lithuania and Exports(as % of merchandise exports) of St. Kitts and Nevis?
Ensure brevity in your answer.  7.13. In the year 2007, what is the difference between the Exports(as % of merchandise exports) in Russian Federation and Exports(as % of merchandise exports) in St. Kitts and Nevis?
Provide a succinct answer. -7.19. In the year 2008, what is the difference between the Exports(as % of merchandise exports) of Cameroon and Exports(as % of merchandise exports) of Lithuania?
Your response must be concise. 16.86. In the year 2008, what is the difference between the Exports(as % of merchandise exports) in Cameroon and Exports(as % of merchandise exports) in Russian Federation?
Ensure brevity in your answer.  30.51. In the year 2008, what is the difference between the Exports(as % of merchandise exports) of Cameroon and Exports(as % of merchandise exports) of St. Kitts and Nevis?
Provide a short and direct response. 22.69. In the year 2008, what is the difference between the Exports(as % of merchandise exports) of Lithuania and Exports(as % of merchandise exports) of Russian Federation?
Your answer should be very brief. 13.64. In the year 2008, what is the difference between the Exports(as % of merchandise exports) in Lithuania and Exports(as % of merchandise exports) in St. Kitts and Nevis?
Give a very brief answer. 5.82. In the year 2008, what is the difference between the Exports(as % of merchandise exports) of Russian Federation and Exports(as % of merchandise exports) of St. Kitts and Nevis?
Your answer should be very brief. -7.82. In the year 2009, what is the difference between the Exports(as % of merchandise exports) of Cameroon and Exports(as % of merchandise exports) of Lithuania?
Keep it short and to the point. 28.91. In the year 2009, what is the difference between the Exports(as % of merchandise exports) in Cameroon and Exports(as % of merchandise exports) in Russian Federation?
Offer a very short reply. 44.59. In the year 2009, what is the difference between the Exports(as % of merchandise exports) of Cameroon and Exports(as % of merchandise exports) of St. Kitts and Nevis?
Make the answer very short. 37.86. In the year 2009, what is the difference between the Exports(as % of merchandise exports) of Lithuania and Exports(as % of merchandise exports) of Russian Federation?
Provide a succinct answer. 15.68. In the year 2009, what is the difference between the Exports(as % of merchandise exports) of Lithuania and Exports(as % of merchandise exports) of St. Kitts and Nevis?
Provide a succinct answer. 8.95. In the year 2009, what is the difference between the Exports(as % of merchandise exports) in Russian Federation and Exports(as % of merchandise exports) in St. Kitts and Nevis?
Provide a succinct answer. -6.72. In the year 2010, what is the difference between the Exports(as % of merchandise exports) in Cameroon and Exports(as % of merchandise exports) in Lithuania?
Offer a very short reply. 7.09. In the year 2010, what is the difference between the Exports(as % of merchandise exports) of Cameroon and Exports(as % of merchandise exports) of Russian Federation?
Keep it short and to the point. 22.54. In the year 2010, what is the difference between the Exports(as % of merchandise exports) of Cameroon and Exports(as % of merchandise exports) of St. Kitts and Nevis?
Your answer should be compact. 12.9. In the year 2010, what is the difference between the Exports(as % of merchandise exports) in Lithuania and Exports(as % of merchandise exports) in Russian Federation?
Offer a terse response. 15.45. In the year 2010, what is the difference between the Exports(as % of merchandise exports) of Lithuania and Exports(as % of merchandise exports) of St. Kitts and Nevis?
Your answer should be very brief. 5.82. In the year 2010, what is the difference between the Exports(as % of merchandise exports) in Russian Federation and Exports(as % of merchandise exports) in St. Kitts and Nevis?
Ensure brevity in your answer.  -9.64. What is the ratio of the Exports(as % of merchandise exports) in Cameroon in 2004 to that in 2005?
Keep it short and to the point. 1.1. What is the ratio of the Exports(as % of merchandise exports) in Lithuania in 2004 to that in 2005?
Your response must be concise. 0.92. What is the ratio of the Exports(as % of merchandise exports) of Russian Federation in 2004 to that in 2005?
Your answer should be very brief. 0.85. What is the ratio of the Exports(as % of merchandise exports) of St. Kitts and Nevis in 2004 to that in 2005?
Ensure brevity in your answer.  6.88. What is the ratio of the Exports(as % of merchandise exports) in Cameroon in 2004 to that in 2006?
Offer a very short reply. 1.56. What is the ratio of the Exports(as % of merchandise exports) in Lithuania in 2004 to that in 2006?
Your answer should be compact. 0.83. What is the ratio of the Exports(as % of merchandise exports) of Russian Federation in 2004 to that in 2006?
Make the answer very short. 0.85. What is the ratio of the Exports(as % of merchandise exports) of St. Kitts and Nevis in 2004 to that in 2006?
Provide a short and direct response. 4. What is the ratio of the Exports(as % of merchandise exports) of Cameroon in 2004 to that in 2007?
Keep it short and to the point. 1.63. What is the ratio of the Exports(as % of merchandise exports) in Lithuania in 2004 to that in 2007?
Your answer should be compact. 0.68. What is the ratio of the Exports(as % of merchandise exports) of Russian Federation in 2004 to that in 2007?
Provide a short and direct response. 0.58. What is the ratio of the Exports(as % of merchandise exports) of St. Kitts and Nevis in 2004 to that in 2007?
Make the answer very short. 3.04. What is the ratio of the Exports(as % of merchandise exports) in Cameroon in 2004 to that in 2008?
Offer a terse response. 0.58. What is the ratio of the Exports(as % of merchandise exports) of Lithuania in 2004 to that in 2008?
Make the answer very short. 0.73. What is the ratio of the Exports(as % of merchandise exports) of Russian Federation in 2004 to that in 2008?
Provide a short and direct response. 0.76. What is the ratio of the Exports(as % of merchandise exports) of St. Kitts and Nevis in 2004 to that in 2008?
Your answer should be very brief. 3.02. What is the ratio of the Exports(as % of merchandise exports) in Cameroon in 2004 to that in 2009?
Your answer should be very brief. 0.39. What is the ratio of the Exports(as % of merchandise exports) of Lithuania in 2004 to that in 2009?
Your response must be concise. 0.6. What is the ratio of the Exports(as % of merchandise exports) of Russian Federation in 2004 to that in 2009?
Your answer should be compact. 0.42. What is the ratio of the Exports(as % of merchandise exports) in St. Kitts and Nevis in 2004 to that in 2009?
Ensure brevity in your answer.  2.91. What is the ratio of the Exports(as % of merchandise exports) in Cameroon in 2004 to that in 2010?
Offer a very short reply. 0.77. What is the ratio of the Exports(as % of merchandise exports) of Lithuania in 2004 to that in 2010?
Provide a short and direct response. 0.65. What is the ratio of the Exports(as % of merchandise exports) of Russian Federation in 2004 to that in 2010?
Ensure brevity in your answer.  0.72. What is the ratio of the Exports(as % of merchandise exports) of St. Kitts and Nevis in 2004 to that in 2010?
Keep it short and to the point. 2.52. What is the ratio of the Exports(as % of merchandise exports) in Cameroon in 2005 to that in 2006?
Make the answer very short. 1.42. What is the ratio of the Exports(as % of merchandise exports) in Lithuania in 2005 to that in 2006?
Provide a succinct answer. 0.9. What is the ratio of the Exports(as % of merchandise exports) in Russian Federation in 2005 to that in 2006?
Your response must be concise. 1. What is the ratio of the Exports(as % of merchandise exports) in St. Kitts and Nevis in 2005 to that in 2006?
Ensure brevity in your answer.  0.58. What is the ratio of the Exports(as % of merchandise exports) in Cameroon in 2005 to that in 2007?
Give a very brief answer. 1.48. What is the ratio of the Exports(as % of merchandise exports) of Lithuania in 2005 to that in 2007?
Ensure brevity in your answer.  0.74. What is the ratio of the Exports(as % of merchandise exports) in Russian Federation in 2005 to that in 2007?
Offer a very short reply. 0.69. What is the ratio of the Exports(as % of merchandise exports) in St. Kitts and Nevis in 2005 to that in 2007?
Keep it short and to the point. 0.44. What is the ratio of the Exports(as % of merchandise exports) in Cameroon in 2005 to that in 2008?
Keep it short and to the point. 0.53. What is the ratio of the Exports(as % of merchandise exports) of Lithuania in 2005 to that in 2008?
Make the answer very short. 0.8. What is the ratio of the Exports(as % of merchandise exports) of Russian Federation in 2005 to that in 2008?
Provide a succinct answer. 0.9. What is the ratio of the Exports(as % of merchandise exports) of St. Kitts and Nevis in 2005 to that in 2008?
Your response must be concise. 0.44. What is the ratio of the Exports(as % of merchandise exports) of Cameroon in 2005 to that in 2009?
Provide a short and direct response. 0.36. What is the ratio of the Exports(as % of merchandise exports) in Lithuania in 2005 to that in 2009?
Your answer should be compact. 0.65. What is the ratio of the Exports(as % of merchandise exports) of Russian Federation in 2005 to that in 2009?
Your response must be concise. 0.49. What is the ratio of the Exports(as % of merchandise exports) of St. Kitts and Nevis in 2005 to that in 2009?
Give a very brief answer. 0.42. What is the ratio of the Exports(as % of merchandise exports) of Cameroon in 2005 to that in 2010?
Offer a very short reply. 0.7. What is the ratio of the Exports(as % of merchandise exports) of Lithuania in 2005 to that in 2010?
Your answer should be compact. 0.71. What is the ratio of the Exports(as % of merchandise exports) of Russian Federation in 2005 to that in 2010?
Ensure brevity in your answer.  0.85. What is the ratio of the Exports(as % of merchandise exports) in St. Kitts and Nevis in 2005 to that in 2010?
Offer a very short reply. 0.37. What is the ratio of the Exports(as % of merchandise exports) in Cameroon in 2006 to that in 2007?
Your answer should be compact. 1.04. What is the ratio of the Exports(as % of merchandise exports) in Lithuania in 2006 to that in 2007?
Make the answer very short. 0.82. What is the ratio of the Exports(as % of merchandise exports) of Russian Federation in 2006 to that in 2007?
Make the answer very short. 0.68. What is the ratio of the Exports(as % of merchandise exports) in St. Kitts and Nevis in 2006 to that in 2007?
Offer a terse response. 0.76. What is the ratio of the Exports(as % of merchandise exports) in Cameroon in 2006 to that in 2008?
Your answer should be very brief. 0.37. What is the ratio of the Exports(as % of merchandise exports) in Lithuania in 2006 to that in 2008?
Offer a terse response. 0.89. What is the ratio of the Exports(as % of merchandise exports) in Russian Federation in 2006 to that in 2008?
Give a very brief answer. 0.9. What is the ratio of the Exports(as % of merchandise exports) of St. Kitts and Nevis in 2006 to that in 2008?
Your answer should be very brief. 0.76. What is the ratio of the Exports(as % of merchandise exports) in Cameroon in 2006 to that in 2009?
Ensure brevity in your answer.  0.25. What is the ratio of the Exports(as % of merchandise exports) of Lithuania in 2006 to that in 2009?
Provide a succinct answer. 0.72. What is the ratio of the Exports(as % of merchandise exports) of Russian Federation in 2006 to that in 2009?
Ensure brevity in your answer.  0.49. What is the ratio of the Exports(as % of merchandise exports) in St. Kitts and Nevis in 2006 to that in 2009?
Your answer should be compact. 0.73. What is the ratio of the Exports(as % of merchandise exports) in Cameroon in 2006 to that in 2010?
Your response must be concise. 0.49. What is the ratio of the Exports(as % of merchandise exports) in Lithuania in 2006 to that in 2010?
Keep it short and to the point. 0.79. What is the ratio of the Exports(as % of merchandise exports) in Russian Federation in 2006 to that in 2010?
Provide a succinct answer. 0.84. What is the ratio of the Exports(as % of merchandise exports) in St. Kitts and Nevis in 2006 to that in 2010?
Make the answer very short. 0.63. What is the ratio of the Exports(as % of merchandise exports) of Cameroon in 2007 to that in 2008?
Your answer should be very brief. 0.36. What is the ratio of the Exports(as % of merchandise exports) of Lithuania in 2007 to that in 2008?
Your answer should be compact. 1.08. What is the ratio of the Exports(as % of merchandise exports) of Russian Federation in 2007 to that in 2008?
Provide a succinct answer. 1.31. What is the ratio of the Exports(as % of merchandise exports) in Cameroon in 2007 to that in 2009?
Your answer should be very brief. 0.24. What is the ratio of the Exports(as % of merchandise exports) of Lithuania in 2007 to that in 2009?
Offer a terse response. 0.88. What is the ratio of the Exports(as % of merchandise exports) of Russian Federation in 2007 to that in 2009?
Offer a terse response. 0.72. What is the ratio of the Exports(as % of merchandise exports) in St. Kitts and Nevis in 2007 to that in 2009?
Give a very brief answer. 0.96. What is the ratio of the Exports(as % of merchandise exports) of Cameroon in 2007 to that in 2010?
Offer a terse response. 0.47. What is the ratio of the Exports(as % of merchandise exports) in Lithuania in 2007 to that in 2010?
Ensure brevity in your answer.  0.96. What is the ratio of the Exports(as % of merchandise exports) in Russian Federation in 2007 to that in 2010?
Make the answer very short. 1.23. What is the ratio of the Exports(as % of merchandise exports) of St. Kitts and Nevis in 2007 to that in 2010?
Offer a terse response. 0.83. What is the ratio of the Exports(as % of merchandise exports) of Cameroon in 2008 to that in 2009?
Offer a terse response. 0.68. What is the ratio of the Exports(as % of merchandise exports) in Lithuania in 2008 to that in 2009?
Provide a short and direct response. 0.82. What is the ratio of the Exports(as % of merchandise exports) in Russian Federation in 2008 to that in 2009?
Your answer should be very brief. 0.55. What is the ratio of the Exports(as % of merchandise exports) of St. Kitts and Nevis in 2008 to that in 2009?
Offer a terse response. 0.96. What is the ratio of the Exports(as % of merchandise exports) of Cameroon in 2008 to that in 2010?
Provide a succinct answer. 1.32. What is the ratio of the Exports(as % of merchandise exports) of Lithuania in 2008 to that in 2010?
Offer a very short reply. 0.89. What is the ratio of the Exports(as % of merchandise exports) in Russian Federation in 2008 to that in 2010?
Your answer should be very brief. 0.94. What is the ratio of the Exports(as % of merchandise exports) of St. Kitts and Nevis in 2008 to that in 2010?
Offer a very short reply. 0.83. What is the ratio of the Exports(as % of merchandise exports) of Cameroon in 2009 to that in 2010?
Keep it short and to the point. 1.96. What is the ratio of the Exports(as % of merchandise exports) of Lithuania in 2009 to that in 2010?
Offer a very short reply. 1.09. What is the ratio of the Exports(as % of merchandise exports) in Russian Federation in 2009 to that in 2010?
Keep it short and to the point. 1.71. What is the ratio of the Exports(as % of merchandise exports) of St. Kitts and Nevis in 2009 to that in 2010?
Provide a succinct answer. 0.86. What is the difference between the highest and the second highest Exports(as % of merchandise exports) in Cameroon?
Give a very brief answer. 15.54. What is the difference between the highest and the second highest Exports(as % of merchandise exports) of Lithuania?
Offer a very short reply. 1.57. What is the difference between the highest and the second highest Exports(as % of merchandise exports) of Russian Federation?
Your answer should be compact. 0.91. What is the difference between the highest and the second highest Exports(as % of merchandise exports) of St. Kitts and Nevis?
Give a very brief answer. 17.47. What is the difference between the highest and the lowest Exports(as % of merchandise exports) of Cameroon?
Your answer should be very brief. 36.28. What is the difference between the highest and the lowest Exports(as % of merchandise exports) in Lithuania?
Provide a succinct answer. 7.6. What is the difference between the highest and the lowest Exports(as % of merchandise exports) in Russian Federation?
Your answer should be compact. 1.88. What is the difference between the highest and the lowest Exports(as % of merchandise exports) in St. Kitts and Nevis?
Make the answer very short. 24.79. 